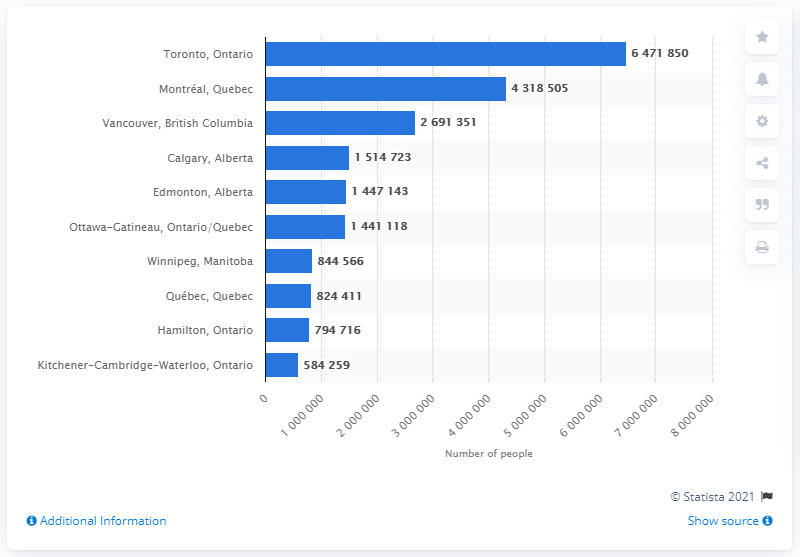Draw attention to some important aspects in this diagram. In 2019, Toronto's population was 6,471,850. 